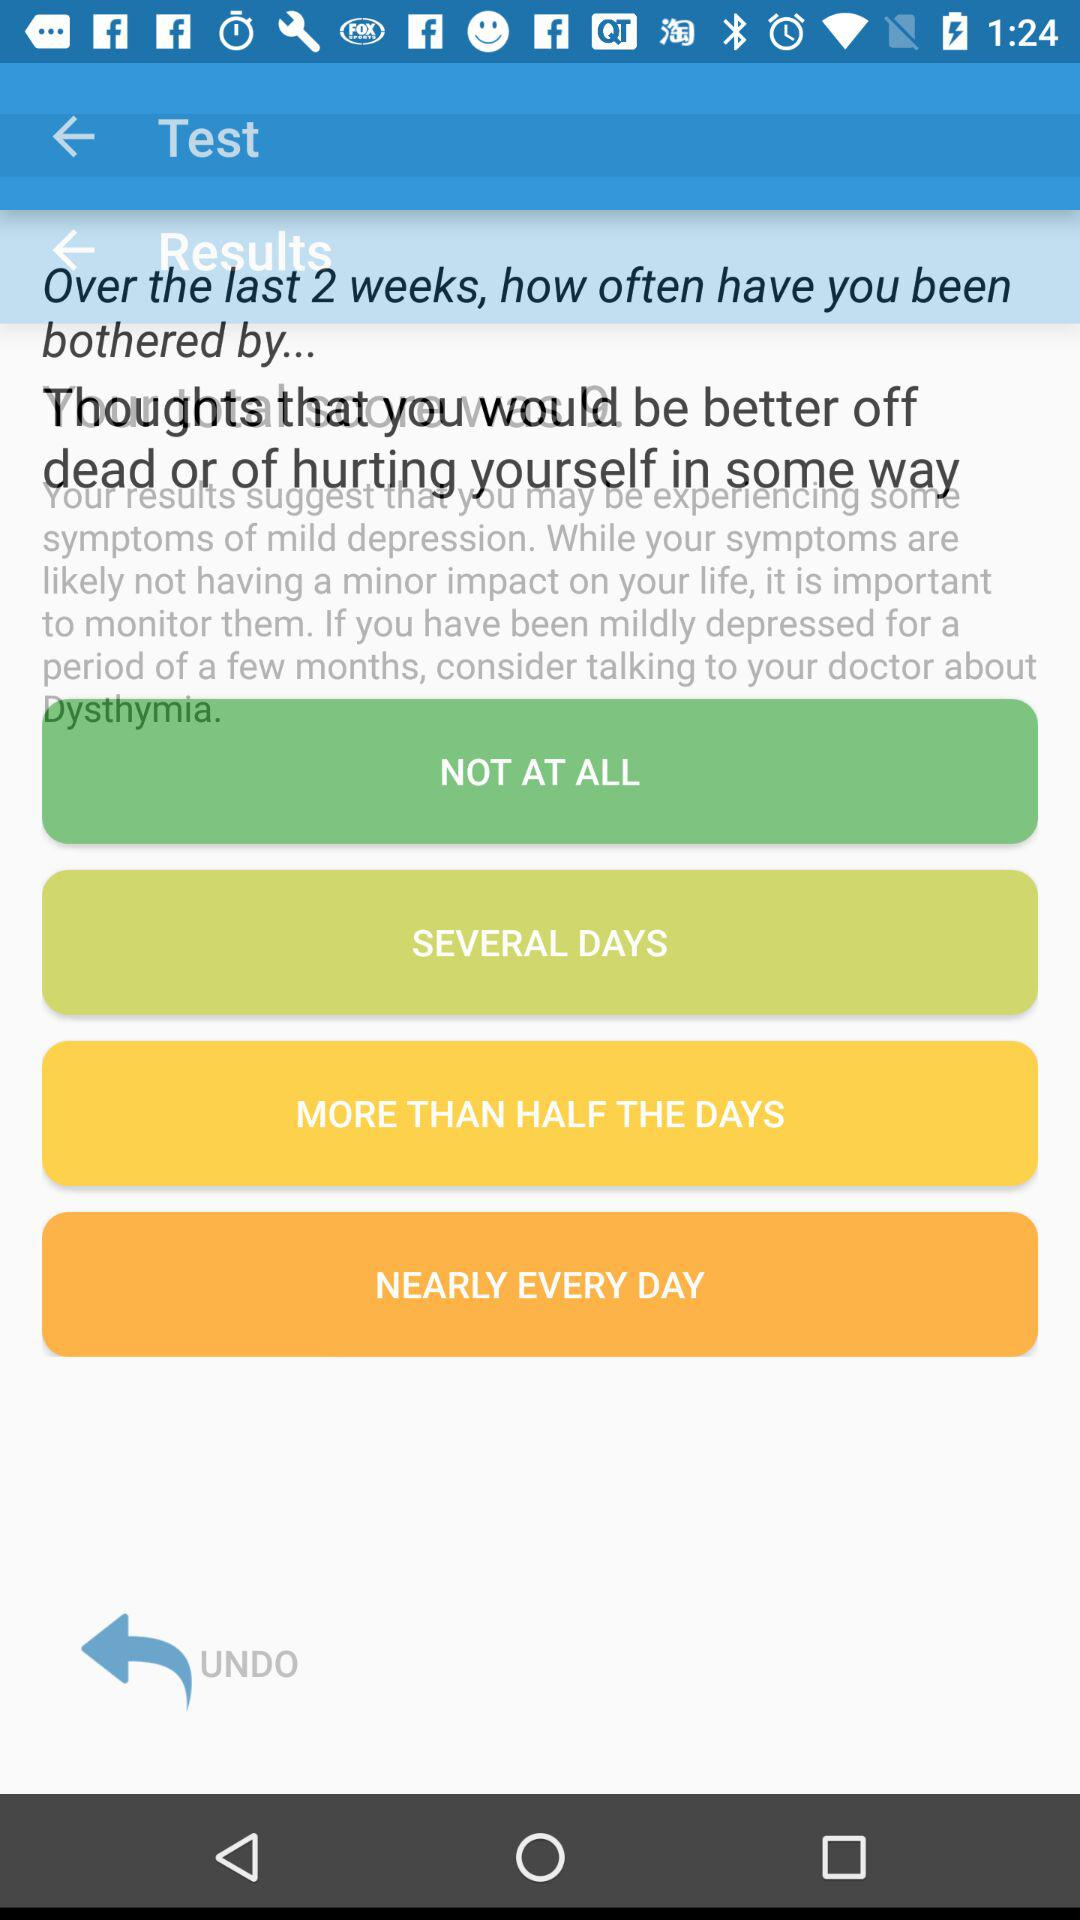How many days are there in the range of options to select from?
Answer the question using a single word or phrase. 4 